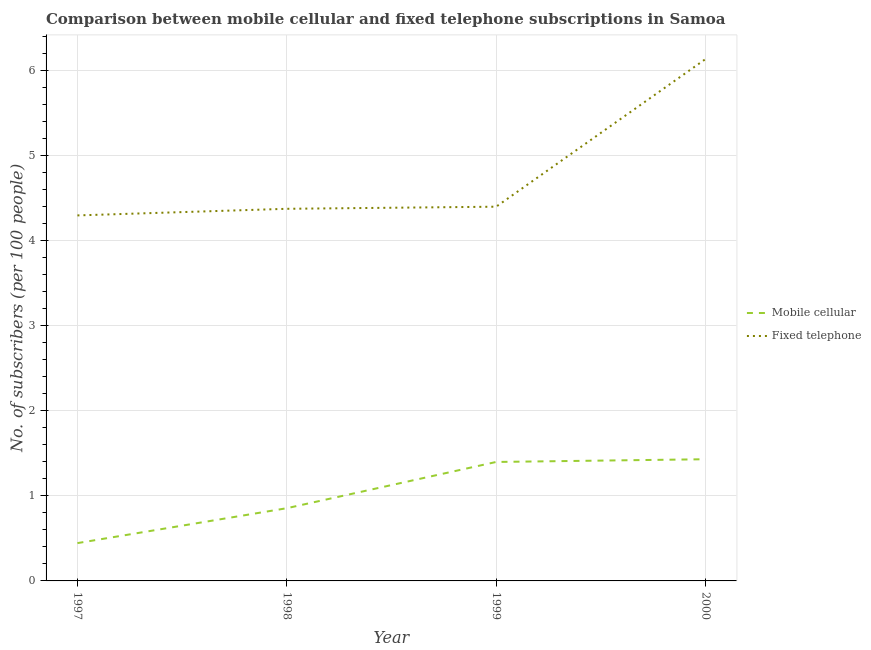What is the number of mobile cellular subscribers in 1999?
Make the answer very short. 1.4. Across all years, what is the maximum number of fixed telephone subscribers?
Ensure brevity in your answer.  6.14. Across all years, what is the minimum number of mobile cellular subscribers?
Provide a short and direct response. 0.44. What is the total number of mobile cellular subscribers in the graph?
Offer a very short reply. 4.13. What is the difference between the number of fixed telephone subscribers in 1998 and that in 1999?
Make the answer very short. -0.02. What is the difference between the number of fixed telephone subscribers in 1999 and the number of mobile cellular subscribers in 1997?
Provide a short and direct response. 3.96. What is the average number of mobile cellular subscribers per year?
Offer a very short reply. 1.03. In the year 1997, what is the difference between the number of mobile cellular subscribers and number of fixed telephone subscribers?
Offer a terse response. -3.86. What is the ratio of the number of mobile cellular subscribers in 1997 to that in 2000?
Your response must be concise. 0.31. Is the difference between the number of fixed telephone subscribers in 1998 and 1999 greater than the difference between the number of mobile cellular subscribers in 1998 and 1999?
Your response must be concise. Yes. What is the difference between the highest and the second highest number of fixed telephone subscribers?
Your response must be concise. 1.74. What is the difference between the highest and the lowest number of mobile cellular subscribers?
Your answer should be compact. 0.99. Is the sum of the number of mobile cellular subscribers in 1998 and 2000 greater than the maximum number of fixed telephone subscribers across all years?
Provide a succinct answer. No. Does the number of fixed telephone subscribers monotonically increase over the years?
Offer a very short reply. Yes. Is the number of fixed telephone subscribers strictly greater than the number of mobile cellular subscribers over the years?
Offer a very short reply. Yes. How many lines are there?
Keep it short and to the point. 2. Are the values on the major ticks of Y-axis written in scientific E-notation?
Give a very brief answer. No. Does the graph contain any zero values?
Your answer should be compact. No. What is the title of the graph?
Keep it short and to the point. Comparison between mobile cellular and fixed telephone subscriptions in Samoa. What is the label or title of the Y-axis?
Keep it short and to the point. No. of subscribers (per 100 people). What is the No. of subscribers (per 100 people) of Mobile cellular in 1997?
Keep it short and to the point. 0.44. What is the No. of subscribers (per 100 people) of Fixed telephone in 1997?
Offer a very short reply. 4.3. What is the No. of subscribers (per 100 people) in Mobile cellular in 1998?
Ensure brevity in your answer.  0.86. What is the No. of subscribers (per 100 people) of Fixed telephone in 1998?
Offer a terse response. 4.38. What is the No. of subscribers (per 100 people) of Mobile cellular in 1999?
Your response must be concise. 1.4. What is the No. of subscribers (per 100 people) of Fixed telephone in 1999?
Your answer should be very brief. 4.4. What is the No. of subscribers (per 100 people) in Mobile cellular in 2000?
Make the answer very short. 1.43. What is the No. of subscribers (per 100 people) in Fixed telephone in 2000?
Provide a succinct answer. 6.14. Across all years, what is the maximum No. of subscribers (per 100 people) of Mobile cellular?
Ensure brevity in your answer.  1.43. Across all years, what is the maximum No. of subscribers (per 100 people) of Fixed telephone?
Provide a succinct answer. 6.14. Across all years, what is the minimum No. of subscribers (per 100 people) in Mobile cellular?
Ensure brevity in your answer.  0.44. Across all years, what is the minimum No. of subscribers (per 100 people) in Fixed telephone?
Make the answer very short. 4.3. What is the total No. of subscribers (per 100 people) in Mobile cellular in the graph?
Make the answer very short. 4.13. What is the total No. of subscribers (per 100 people) in Fixed telephone in the graph?
Make the answer very short. 19.22. What is the difference between the No. of subscribers (per 100 people) of Mobile cellular in 1997 and that in 1998?
Give a very brief answer. -0.41. What is the difference between the No. of subscribers (per 100 people) of Fixed telephone in 1997 and that in 1998?
Your answer should be very brief. -0.08. What is the difference between the No. of subscribers (per 100 people) in Mobile cellular in 1997 and that in 1999?
Give a very brief answer. -0.95. What is the difference between the No. of subscribers (per 100 people) in Fixed telephone in 1997 and that in 1999?
Offer a terse response. -0.1. What is the difference between the No. of subscribers (per 100 people) of Mobile cellular in 1997 and that in 2000?
Keep it short and to the point. -0.99. What is the difference between the No. of subscribers (per 100 people) in Fixed telephone in 1997 and that in 2000?
Keep it short and to the point. -1.84. What is the difference between the No. of subscribers (per 100 people) of Mobile cellular in 1998 and that in 1999?
Keep it short and to the point. -0.54. What is the difference between the No. of subscribers (per 100 people) of Fixed telephone in 1998 and that in 1999?
Offer a terse response. -0.02. What is the difference between the No. of subscribers (per 100 people) in Mobile cellular in 1998 and that in 2000?
Provide a succinct answer. -0.58. What is the difference between the No. of subscribers (per 100 people) in Fixed telephone in 1998 and that in 2000?
Offer a very short reply. -1.76. What is the difference between the No. of subscribers (per 100 people) of Mobile cellular in 1999 and that in 2000?
Keep it short and to the point. -0.03. What is the difference between the No. of subscribers (per 100 people) of Fixed telephone in 1999 and that in 2000?
Offer a very short reply. -1.74. What is the difference between the No. of subscribers (per 100 people) in Mobile cellular in 1997 and the No. of subscribers (per 100 people) in Fixed telephone in 1998?
Offer a terse response. -3.93. What is the difference between the No. of subscribers (per 100 people) of Mobile cellular in 1997 and the No. of subscribers (per 100 people) of Fixed telephone in 1999?
Make the answer very short. -3.96. What is the difference between the No. of subscribers (per 100 people) of Mobile cellular in 1997 and the No. of subscribers (per 100 people) of Fixed telephone in 2000?
Make the answer very short. -5.69. What is the difference between the No. of subscribers (per 100 people) of Mobile cellular in 1998 and the No. of subscribers (per 100 people) of Fixed telephone in 1999?
Provide a short and direct response. -3.55. What is the difference between the No. of subscribers (per 100 people) in Mobile cellular in 1998 and the No. of subscribers (per 100 people) in Fixed telephone in 2000?
Provide a short and direct response. -5.28. What is the difference between the No. of subscribers (per 100 people) in Mobile cellular in 1999 and the No. of subscribers (per 100 people) in Fixed telephone in 2000?
Make the answer very short. -4.74. What is the average No. of subscribers (per 100 people) of Mobile cellular per year?
Offer a very short reply. 1.03. What is the average No. of subscribers (per 100 people) of Fixed telephone per year?
Make the answer very short. 4.81. In the year 1997, what is the difference between the No. of subscribers (per 100 people) of Mobile cellular and No. of subscribers (per 100 people) of Fixed telephone?
Provide a succinct answer. -3.86. In the year 1998, what is the difference between the No. of subscribers (per 100 people) of Mobile cellular and No. of subscribers (per 100 people) of Fixed telephone?
Ensure brevity in your answer.  -3.52. In the year 1999, what is the difference between the No. of subscribers (per 100 people) in Mobile cellular and No. of subscribers (per 100 people) in Fixed telephone?
Provide a succinct answer. -3. In the year 2000, what is the difference between the No. of subscribers (per 100 people) of Mobile cellular and No. of subscribers (per 100 people) of Fixed telephone?
Offer a very short reply. -4.71. What is the ratio of the No. of subscribers (per 100 people) of Mobile cellular in 1997 to that in 1998?
Offer a very short reply. 0.52. What is the ratio of the No. of subscribers (per 100 people) of Fixed telephone in 1997 to that in 1998?
Your answer should be very brief. 0.98. What is the ratio of the No. of subscribers (per 100 people) in Mobile cellular in 1997 to that in 1999?
Ensure brevity in your answer.  0.32. What is the ratio of the No. of subscribers (per 100 people) in Fixed telephone in 1997 to that in 1999?
Your answer should be compact. 0.98. What is the ratio of the No. of subscribers (per 100 people) of Mobile cellular in 1997 to that in 2000?
Your answer should be compact. 0.31. What is the ratio of the No. of subscribers (per 100 people) in Fixed telephone in 1997 to that in 2000?
Provide a succinct answer. 0.7. What is the ratio of the No. of subscribers (per 100 people) of Mobile cellular in 1998 to that in 1999?
Make the answer very short. 0.61. What is the ratio of the No. of subscribers (per 100 people) in Fixed telephone in 1998 to that in 1999?
Ensure brevity in your answer.  0.99. What is the ratio of the No. of subscribers (per 100 people) of Mobile cellular in 1998 to that in 2000?
Make the answer very short. 0.6. What is the ratio of the No. of subscribers (per 100 people) in Fixed telephone in 1998 to that in 2000?
Provide a short and direct response. 0.71. What is the ratio of the No. of subscribers (per 100 people) of Mobile cellular in 1999 to that in 2000?
Offer a very short reply. 0.98. What is the ratio of the No. of subscribers (per 100 people) of Fixed telephone in 1999 to that in 2000?
Ensure brevity in your answer.  0.72. What is the difference between the highest and the second highest No. of subscribers (per 100 people) in Mobile cellular?
Give a very brief answer. 0.03. What is the difference between the highest and the second highest No. of subscribers (per 100 people) in Fixed telephone?
Provide a succinct answer. 1.74. What is the difference between the highest and the lowest No. of subscribers (per 100 people) of Mobile cellular?
Ensure brevity in your answer.  0.99. What is the difference between the highest and the lowest No. of subscribers (per 100 people) in Fixed telephone?
Make the answer very short. 1.84. 